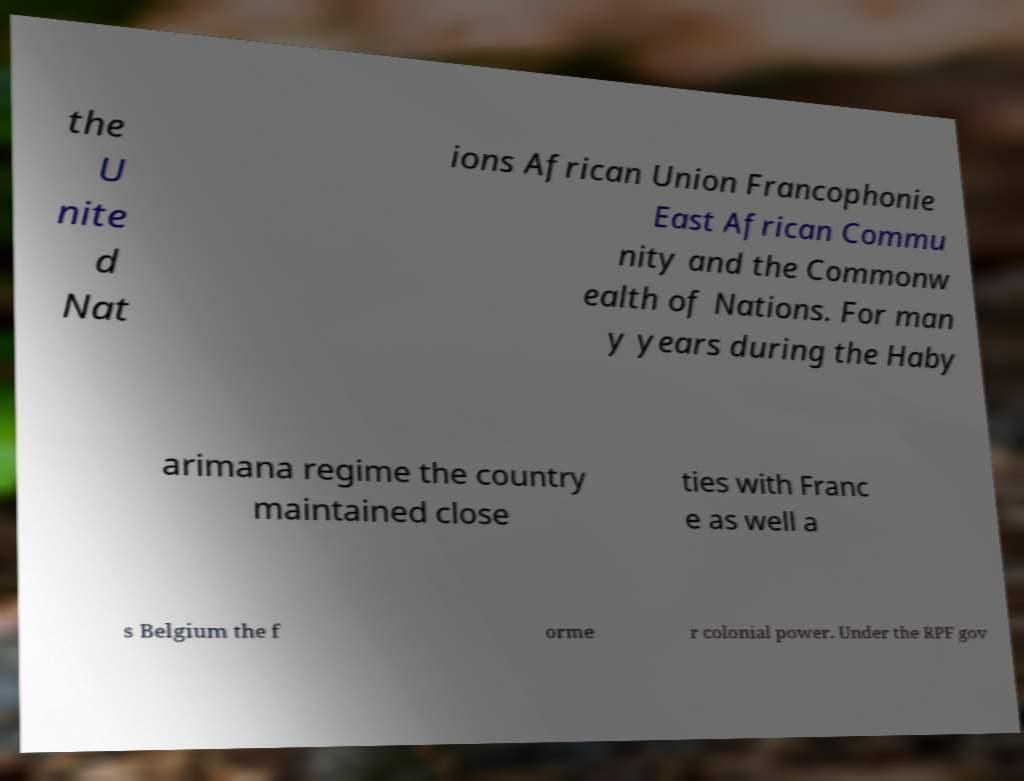Can you read and provide the text displayed in the image?This photo seems to have some interesting text. Can you extract and type it out for me? the U nite d Nat ions African Union Francophonie East African Commu nity and the Commonw ealth of Nations. For man y years during the Haby arimana regime the country maintained close ties with Franc e as well a s Belgium the f orme r colonial power. Under the RPF gov 